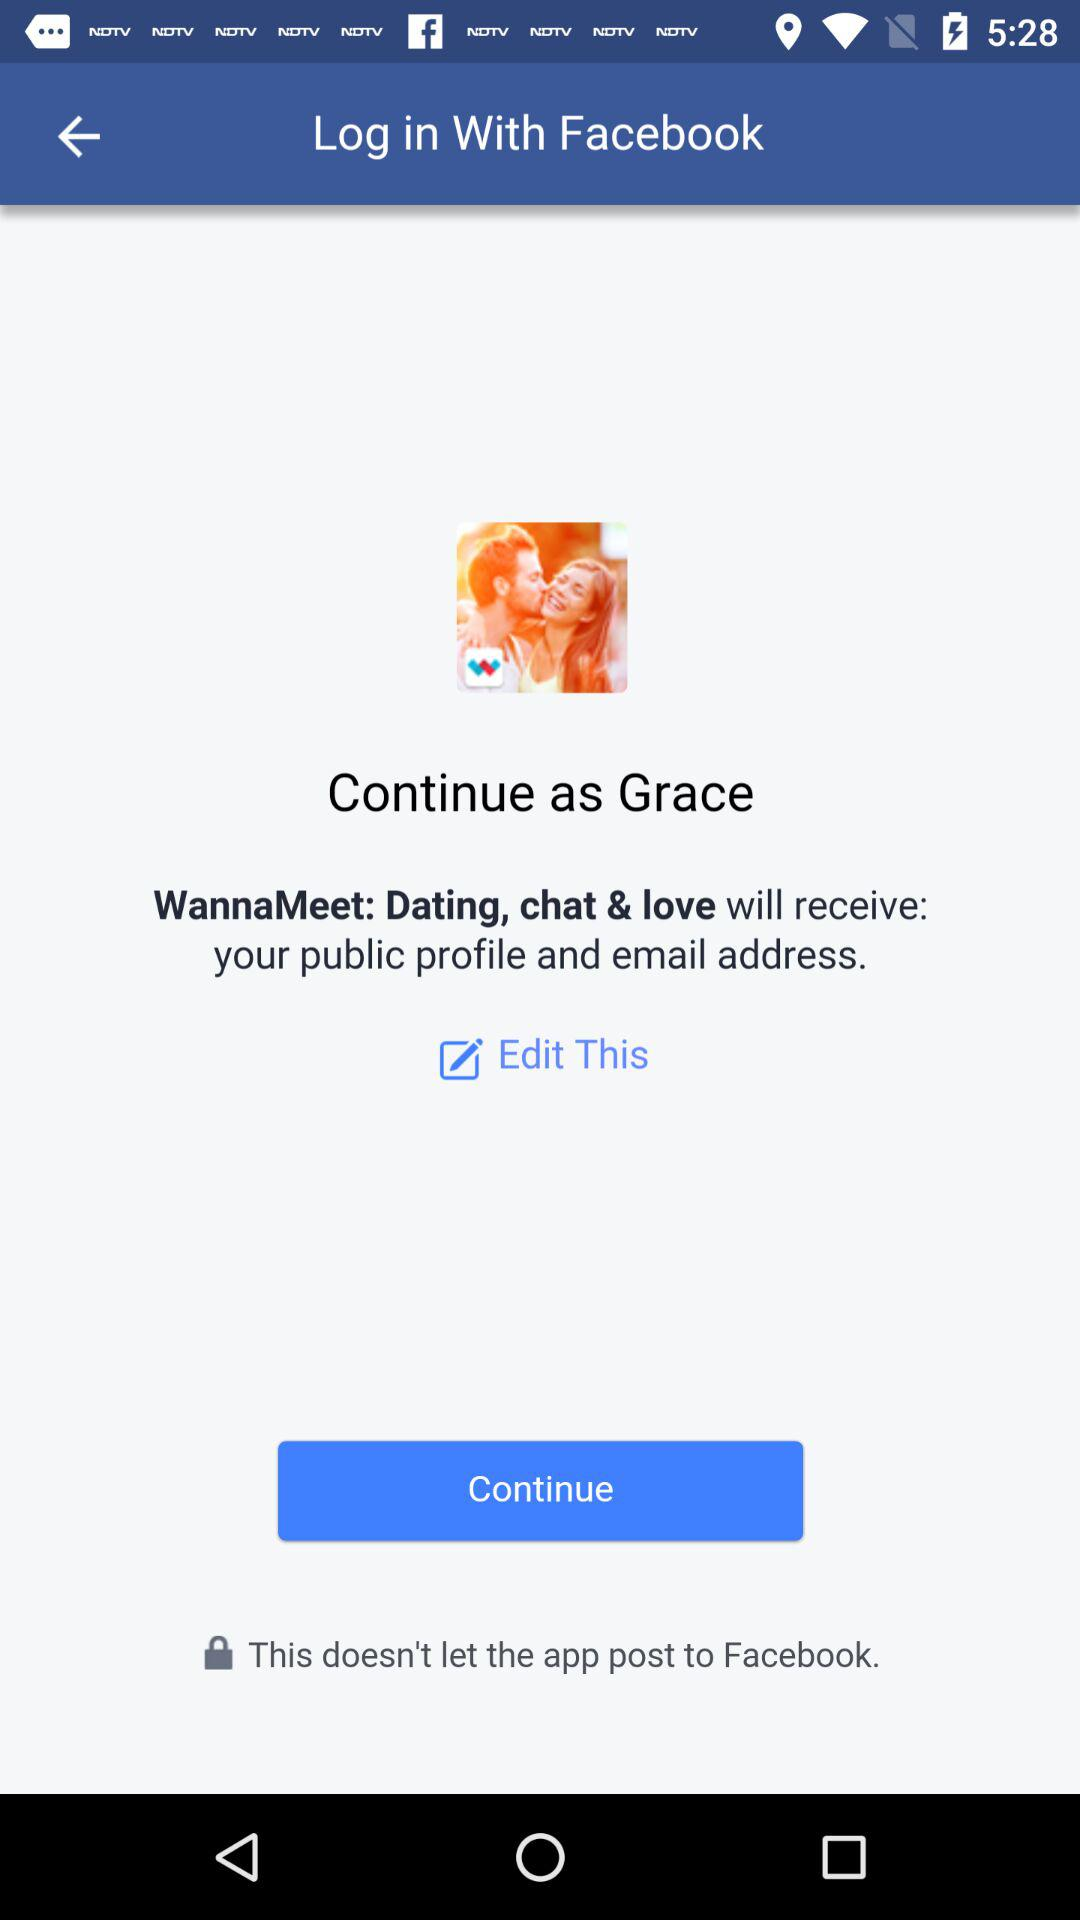Who will get my email address and public profile? The application that will get your email address and public profile is "WannaMeet: Dating, chat & love". 